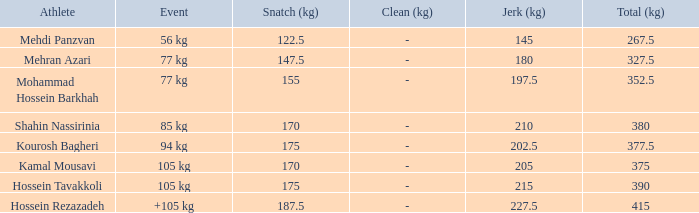How many snatches were there with a total of 267.5? 0.0. 